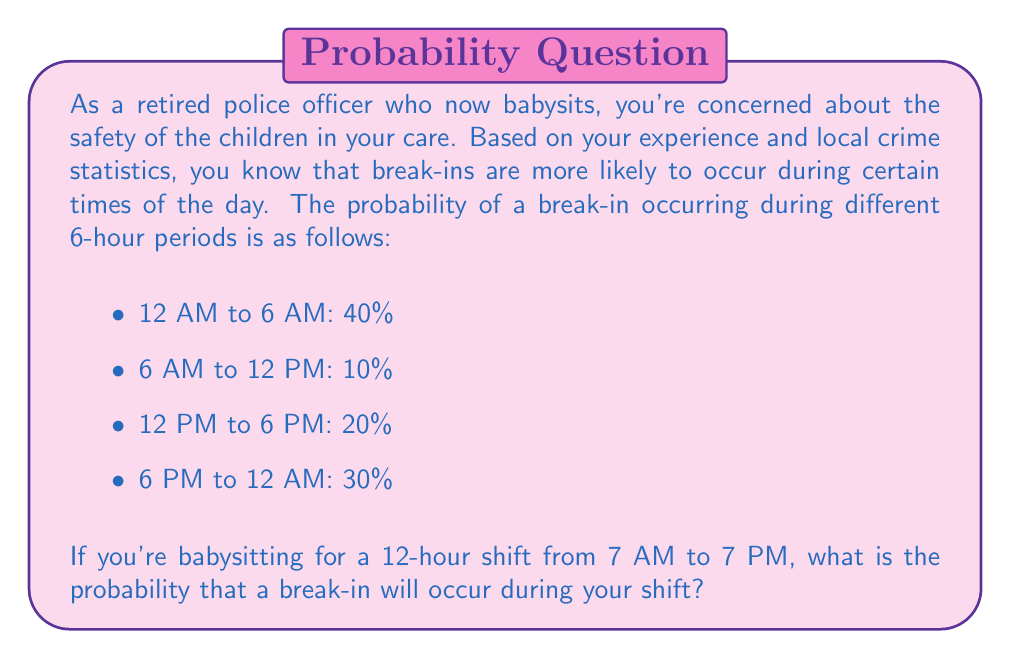Solve this math problem. To solve this problem, we need to follow these steps:

1. Identify the relevant time periods for the 12-hour shift (7 AM to 7 PM).
2. Calculate the probability of a break-in for each relevant time period.
3. Sum these probabilities to get the total probability for the shift.

Let's break it down:

1. The 12-hour shift (7 AM to 7 PM) spans three of the given time periods:
   - 5 hours of the "6 AM to 12 PM" period
   - 6 hours of the "12 PM to 6 PM" period
   - 1 hour of the "6 PM to 12 AM" period

2. Calculate the probability for each relevant period:
   - 6 AM to 12 PM: $\frac{5}{6} \times 10\% = 8.33\%$
   - 12 PM to 6 PM: $20\%$ (full period)
   - 6 PM to 12 AM: $\frac{1}{6} \times 30\% = 5\%$

3. Sum the probabilities:
   $$P(\text{break-in during shift}) = 8.33\% + 20\% + 5\% = 33.33\%$$

Therefore, the probability of a break-in occurring during your 12-hour shift is approximately 33.33% or $\frac{1}{3}$.
Answer: The probability of a break-in occurring during the 12-hour shift from 7 AM to 7 PM is approximately 33.33% or $\frac{1}{3}$. 